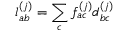Convert formula to latex. <formula><loc_0><loc_0><loc_500><loc_500>\mathcal { l } _ { a b } ^ { ( j ) } = \sum _ { c } \mathcal { f } _ { a c } ^ { ( j ) } \mathcal { d } _ { b c } ^ { ( j ) }</formula> 